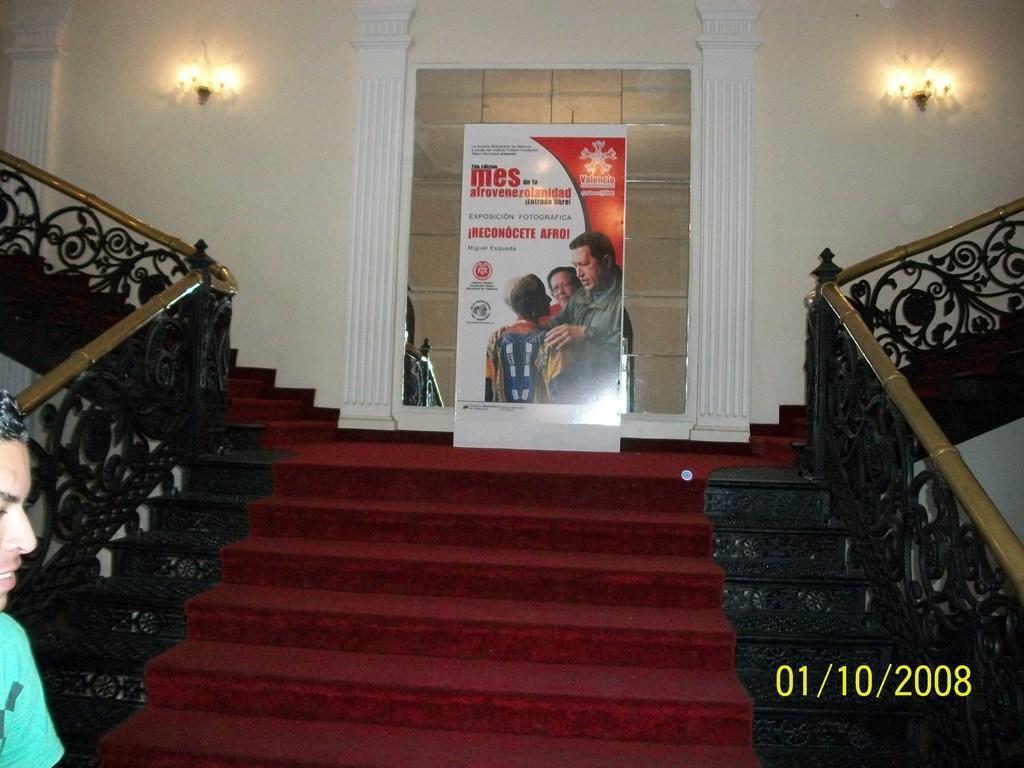Could you give a brief overview of what you see in this image? In this image we can see some stairs on which there is red color carpet, there is black color fencing on left and right side of the image and in the background of the image there is poster attached to the glass wall and there are some lights also attached to the wall and on left side of the image we can see a person wearing green color dress. 